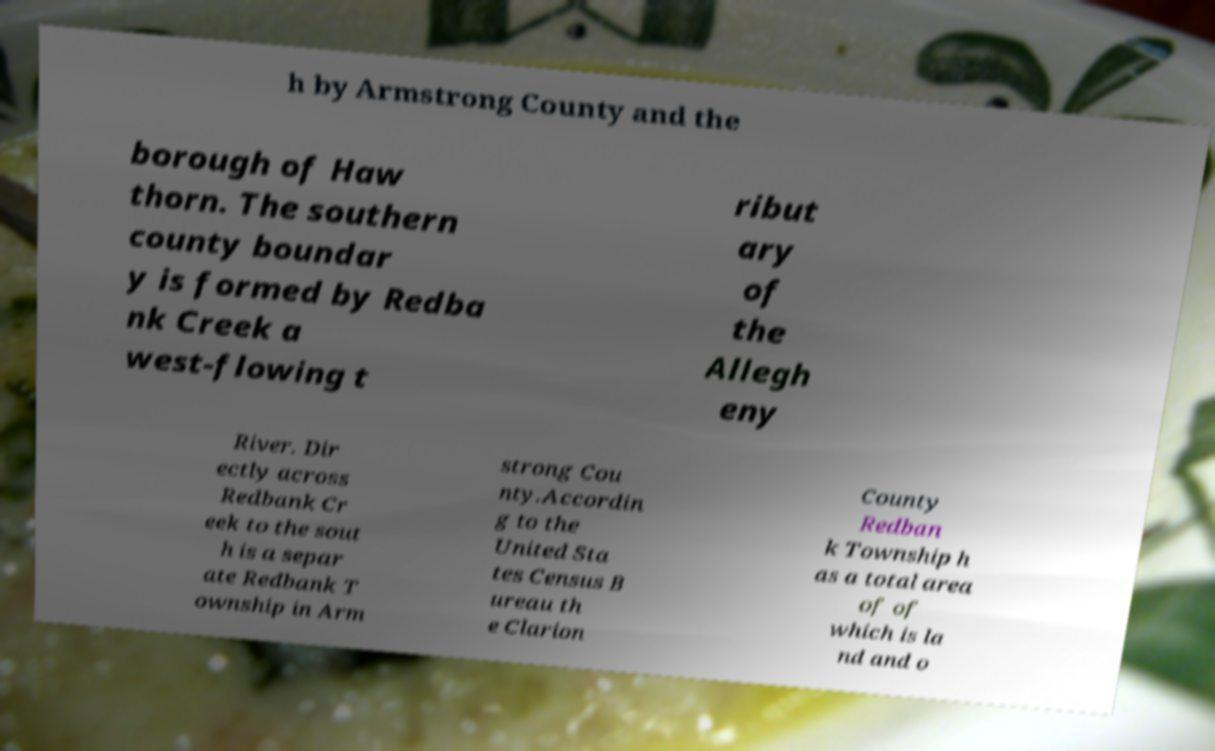Please identify and transcribe the text found in this image. h by Armstrong County and the borough of Haw thorn. The southern county boundar y is formed by Redba nk Creek a west-flowing t ribut ary of the Allegh eny River. Dir ectly across Redbank Cr eek to the sout h is a separ ate Redbank T ownship in Arm strong Cou nty.Accordin g to the United Sta tes Census B ureau th e Clarion County Redban k Township h as a total area of of which is la nd and o 